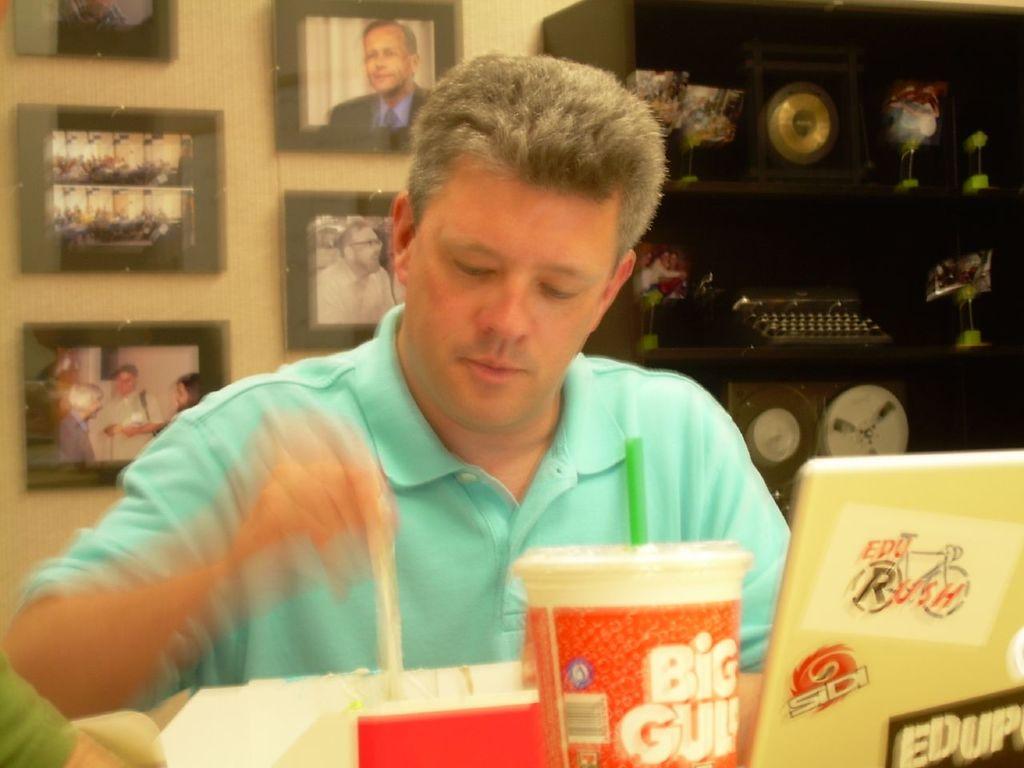Is that a cup a small gulp or a big gulp?
Provide a short and direct response. Big gulp. What stick is on his laptop?
Provide a short and direct response. Edu rush. 